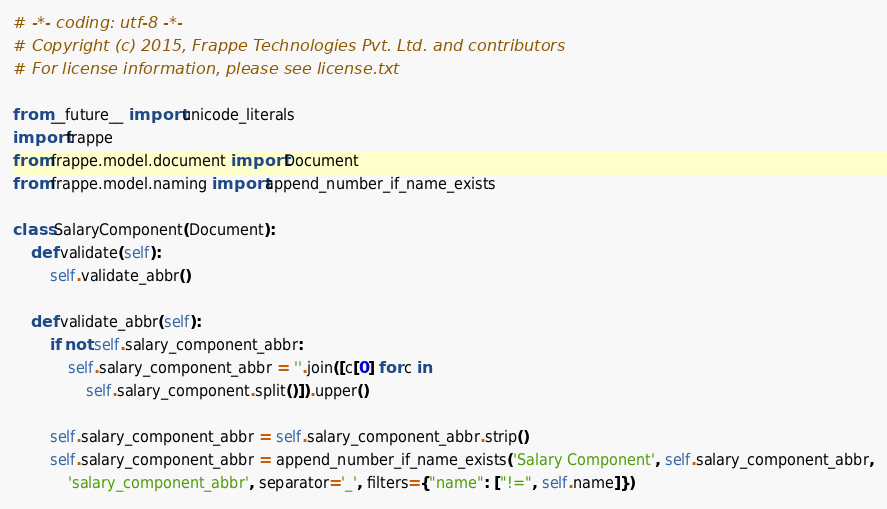<code> <loc_0><loc_0><loc_500><loc_500><_Python_># -*- coding: utf-8 -*-
# Copyright (c) 2015, Frappe Technologies Pvt. Ltd. and contributors
# For license information, please see license.txt

from __future__ import unicode_literals
import frappe
from frappe.model.document import Document
from frappe.model.naming import append_number_if_name_exists

class SalaryComponent(Document):
	def validate(self):
		self.validate_abbr()

	def validate_abbr(self):
		if not self.salary_component_abbr:
			self.salary_component_abbr = ''.join([c[0] for c in
				self.salary_component.split()]).upper()

		self.salary_component_abbr = self.salary_component_abbr.strip()
		self.salary_component_abbr = append_number_if_name_exists('Salary Component', self.salary_component_abbr,
			'salary_component_abbr', separator='_', filters={"name": ["!=", self.name]})</code> 